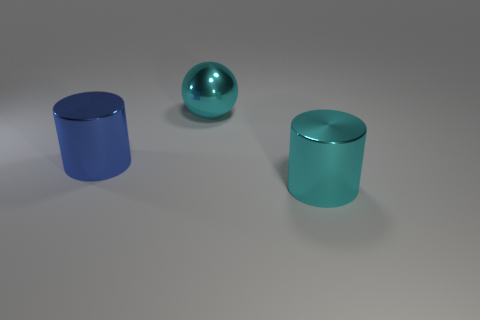Add 2 small green spheres. How many objects exist? 5 Subtract 0 blue balls. How many objects are left? 3 Subtract all spheres. How many objects are left? 2 Subtract all yellow cylinders. Subtract all yellow spheres. How many cylinders are left? 2 Subtract all big objects. Subtract all tiny yellow things. How many objects are left? 0 Add 1 blue objects. How many blue objects are left? 2 Add 2 large blue shiny objects. How many large blue shiny objects exist? 3 